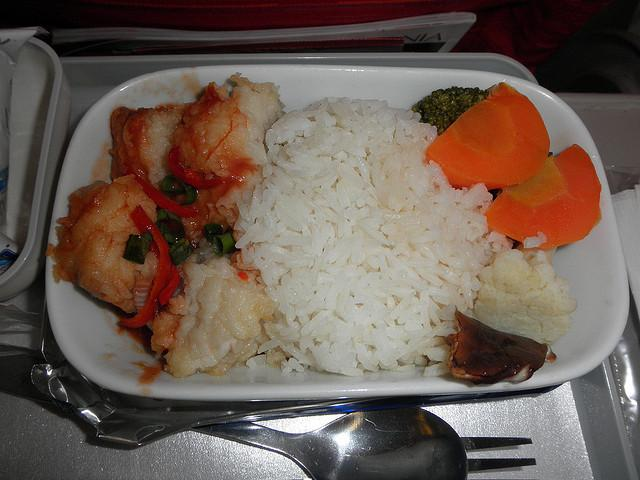On which plant does the vegetable that is reddest here grow? pepper 